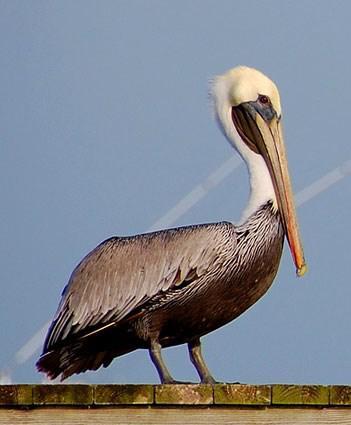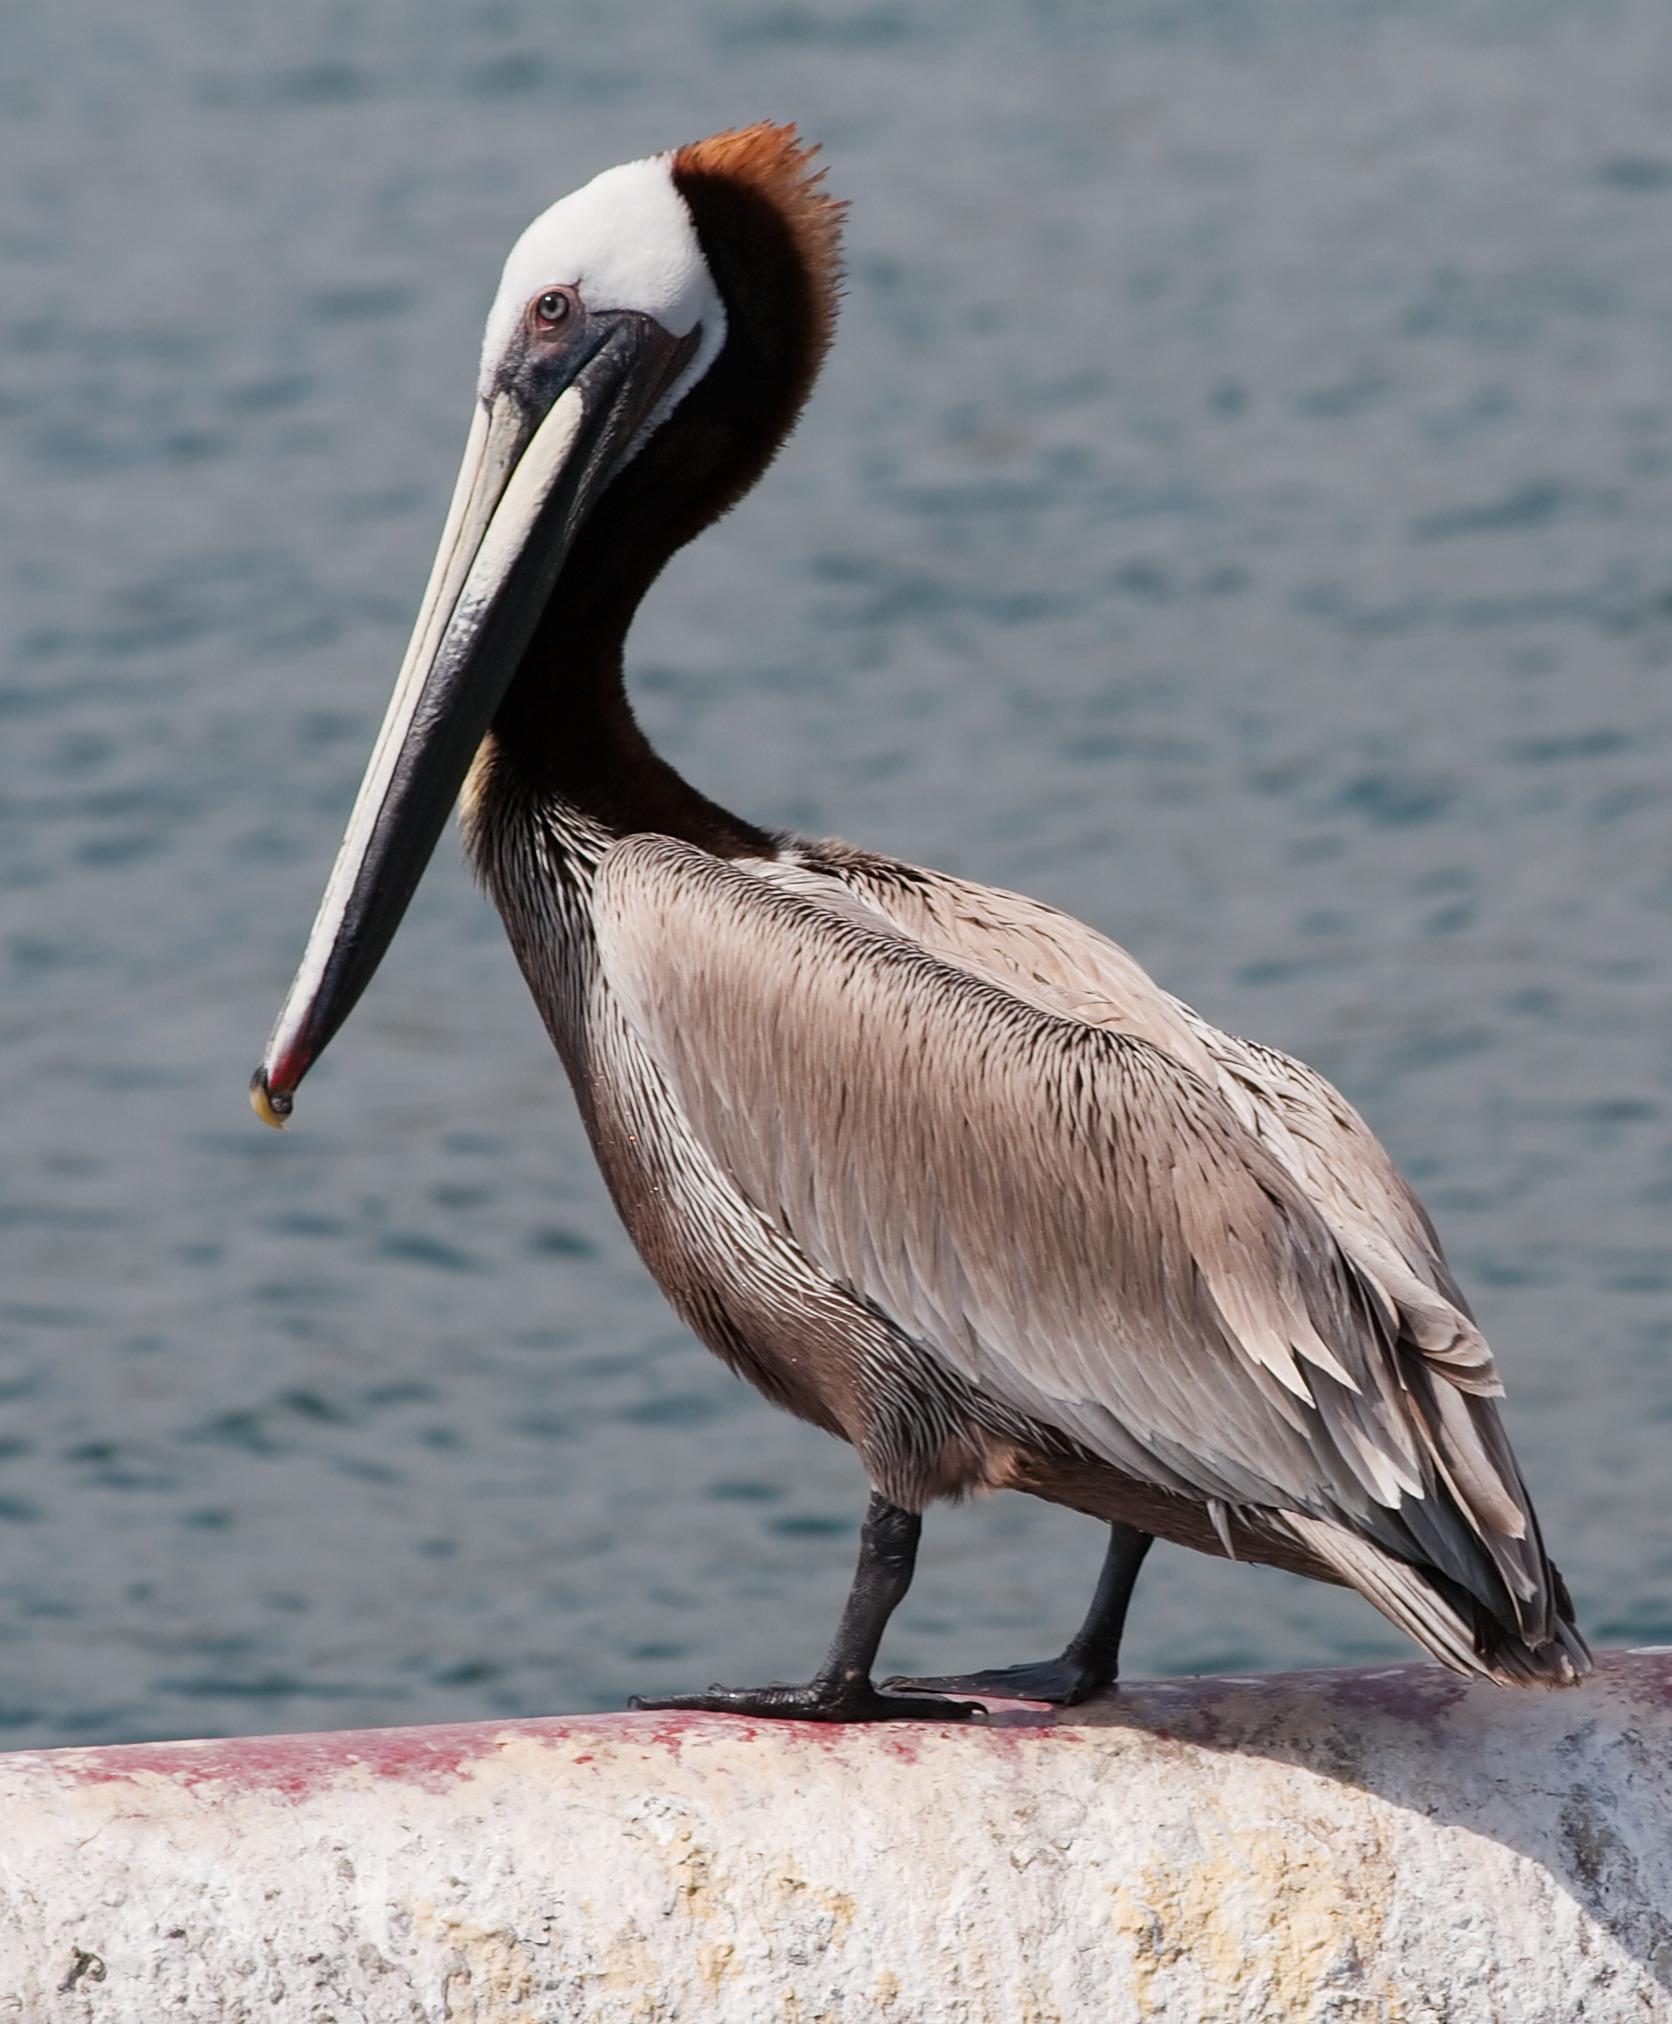The first image is the image on the left, the second image is the image on the right. Examine the images to the left and right. Is the description "The right image shows a pelican afloat on the water." accurate? Answer yes or no. No. 